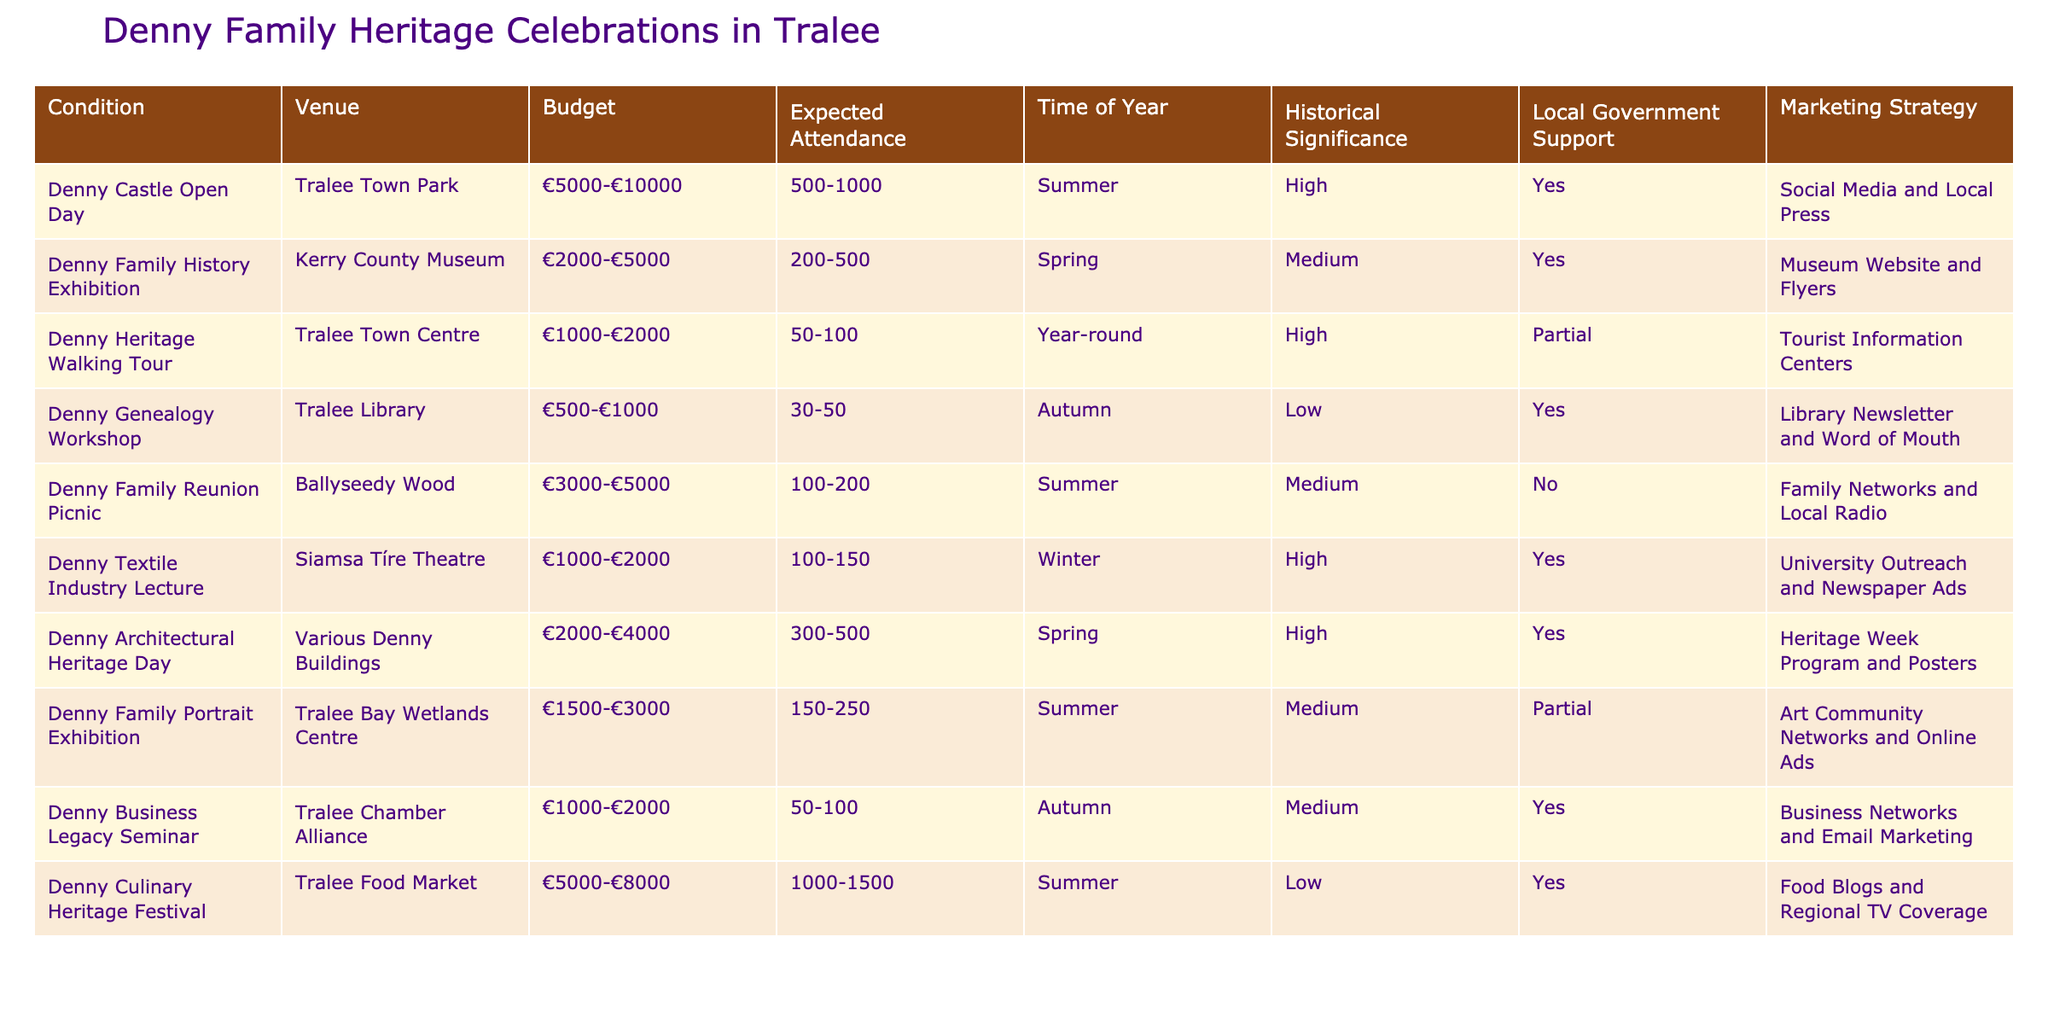What is the expected attendance for the Denny Culinary Heritage Festival? Referring to the table, the expected attendance for the Denny Culinary Heritage Festival is listed as 1000-1500.
Answer: 1000-1500 Which venue has the highest historical significance? Looking at the historical significance column, Denny Castle Open Day, Denny Heritage Walking Tour, Denny Textile Industry Lecture, and Denny Architectural Heritage Day all have a high significance.
Answer: Denny Castle Open Day, Denny Heritage Walking Tour, Denny Textile Industry Lecture, Denny Architectural Heritage Day What is the budget range for the Denny Family History Exhibition? The budget range for the Denny Family History Exhibition, according to the table, is €2000-€5000.
Answer: €2000-€5000 How many events have local government support? By examining the local government support column, there are five events that have support: Denny Castle Open Day, Denny Family History Exhibition, Denny Genealogy Workshop, Denny Textile Industry Lecture, and Denny Architectural Heritage Day.
Answer: Five events What is the lowest expected attendance for events held in Autumn? The events in Autumn are the Denny Genealogy Workshop and the Denny Business Legacy Seminar, with expected attendances of 30-50 and 50-100, respectively. Thus, the lowest expected attendance is 30-50.
Answer: 30-50 What is the average budget of events with high historical significance during the summer? The relevant events are the Denny Castle Open Day (€5000-€10000) and Denny Culinary Heritage Festival (€5000-€8000). To find the average, we can take the average of the budget ranges: (7500 + 6500) / 2 = 7000.
Answer: €7000 Do any events occur year-round? The table lists the Denny Heritage Walking Tour as the only event that occurs year-round.
Answer: Yes, one event Which marketing strategy is used for the Denny Architectural Heritage Day? The marketing strategy for the Denny Architectural Heritage Day is the Heritage Week Program and Posters, as shown in the marketing strategy column.
Answer: Heritage Week Program and Posters How many events have an expected attendance of more than 500 people? The events with expected attendance over 500 are Denny Castle Open Day (500-1000), Denny Culinary Heritage Festival (1000-1500), and Denny Architectural Heritage Day (300-500). Thus, 3 events fit this criterion.
Answer: 3 events 